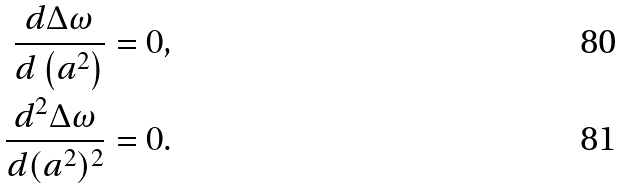<formula> <loc_0><loc_0><loc_500><loc_500>\frac { d \Delta \omega } { d \left ( a ^ { 2 } \right ) } = 0 , \\ \frac { d ^ { 2 } \Delta \omega } { d ( a ^ { 2 } ) ^ { 2 } } = 0 .</formula> 